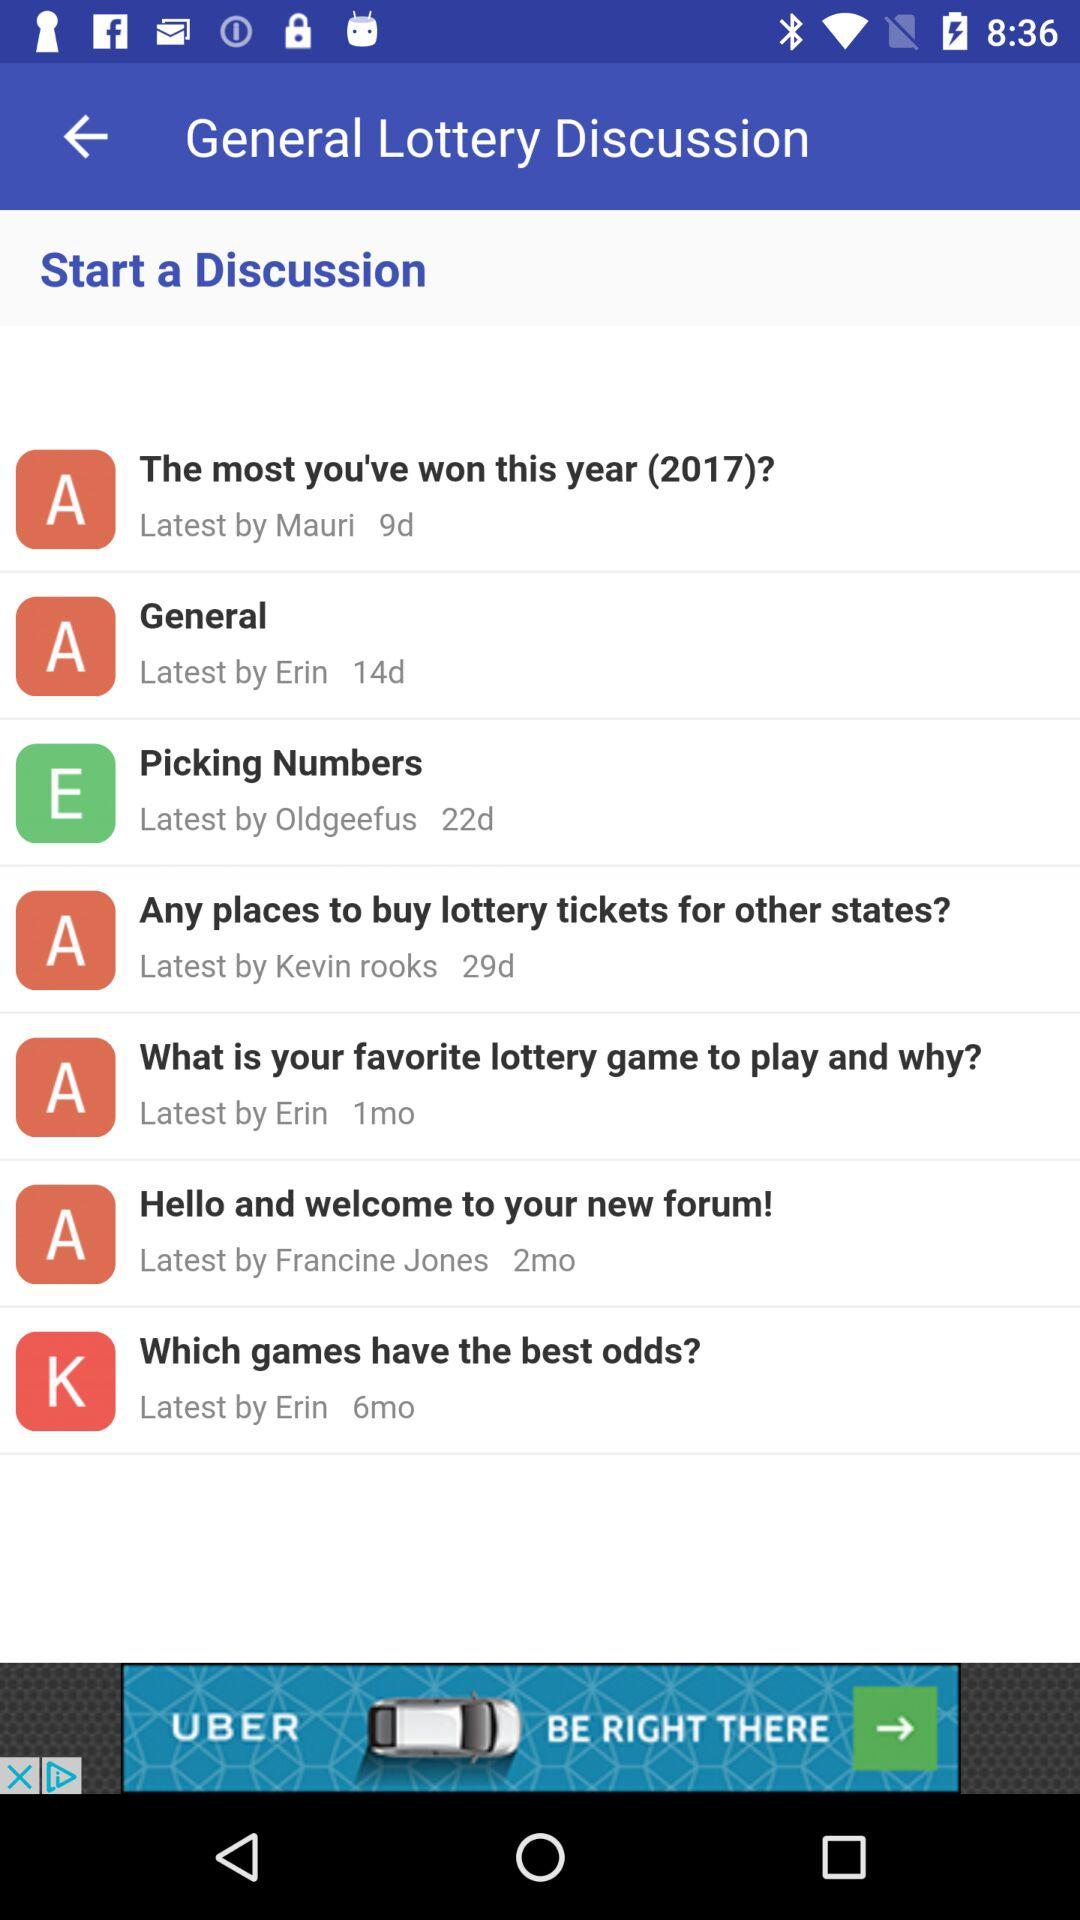How much is the lottery jackpot?
When the provided information is insufficient, respond with <no answer>. <no answer> 